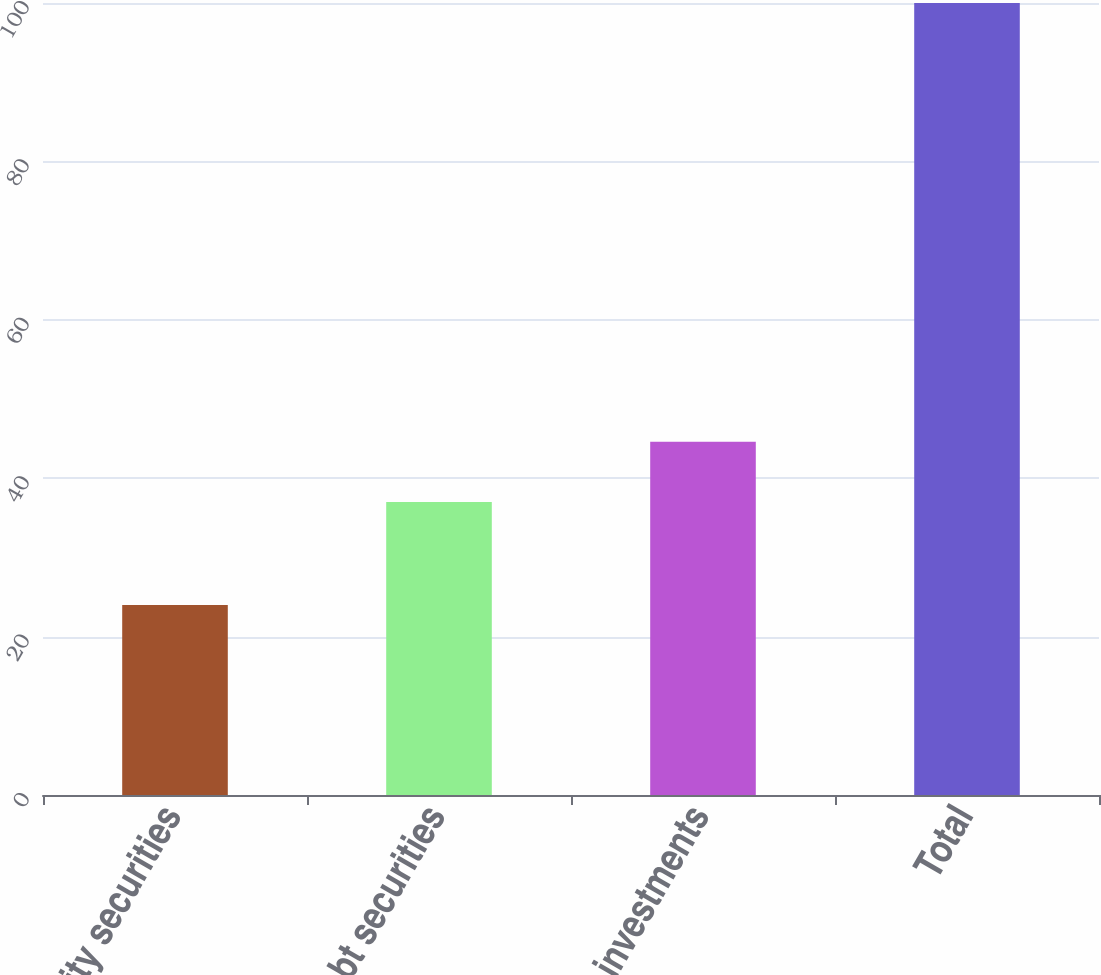Convert chart to OTSL. <chart><loc_0><loc_0><loc_500><loc_500><bar_chart><fcel>Equity securities<fcel>Debt securities<fcel>Other investments<fcel>Total<nl><fcel>24<fcel>37<fcel>44.6<fcel>100<nl></chart> 